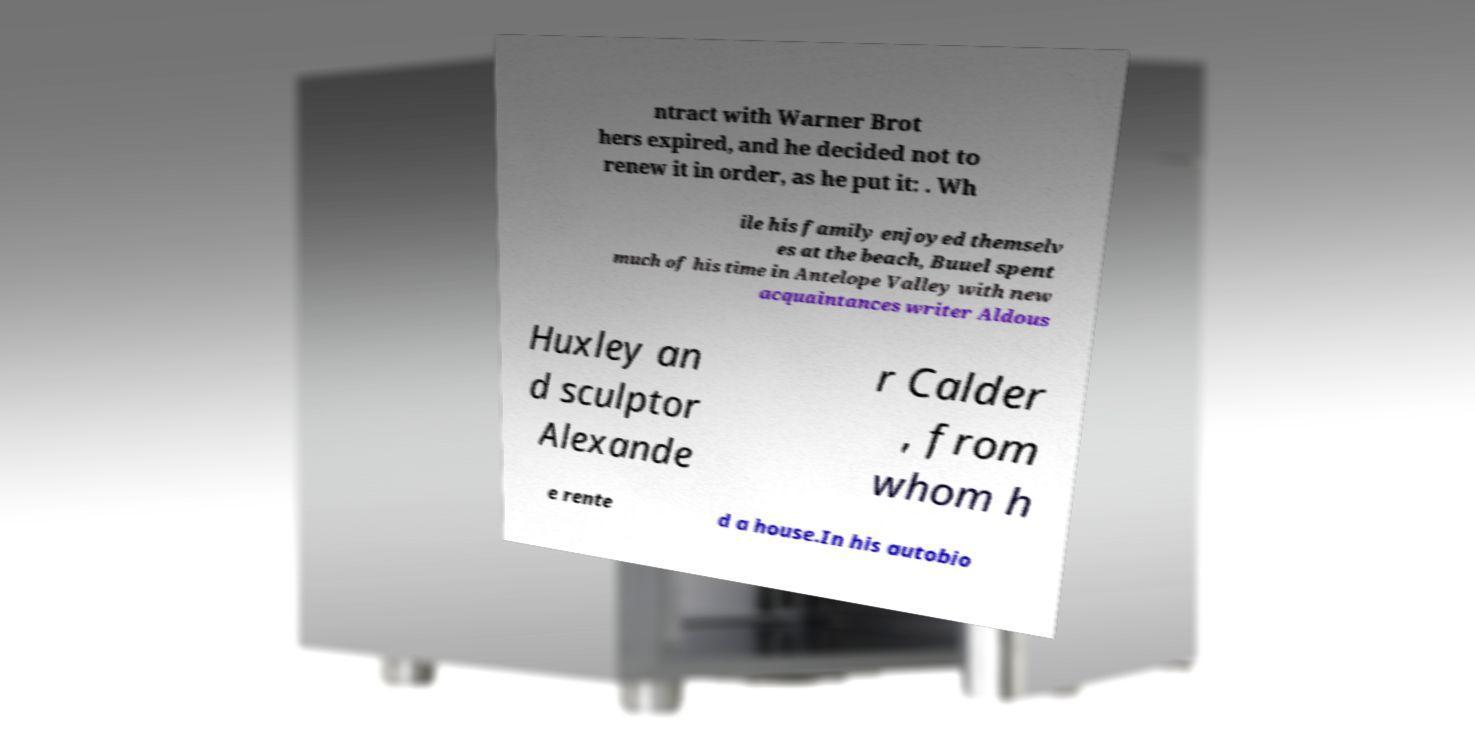There's text embedded in this image that I need extracted. Can you transcribe it verbatim? ntract with Warner Brot hers expired, and he decided not to renew it in order, as he put it: . Wh ile his family enjoyed themselv es at the beach, Buuel spent much of his time in Antelope Valley with new acquaintances writer Aldous Huxley an d sculptor Alexande r Calder , from whom h e rente d a house.In his autobio 